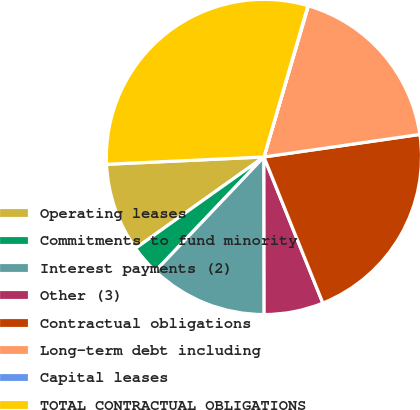Convert chart. <chart><loc_0><loc_0><loc_500><loc_500><pie_chart><fcel>Operating leases<fcel>Commitments to fund minority<fcel>Interest payments (2)<fcel>Other (3)<fcel>Contractual obligations<fcel>Long-term debt including<fcel>Capital leases<fcel>TOTAL CONTRACTUAL OBLIGATIONS<nl><fcel>9.1%<fcel>3.06%<fcel>12.12%<fcel>6.08%<fcel>21.18%<fcel>18.16%<fcel>0.05%<fcel>30.24%<nl></chart> 